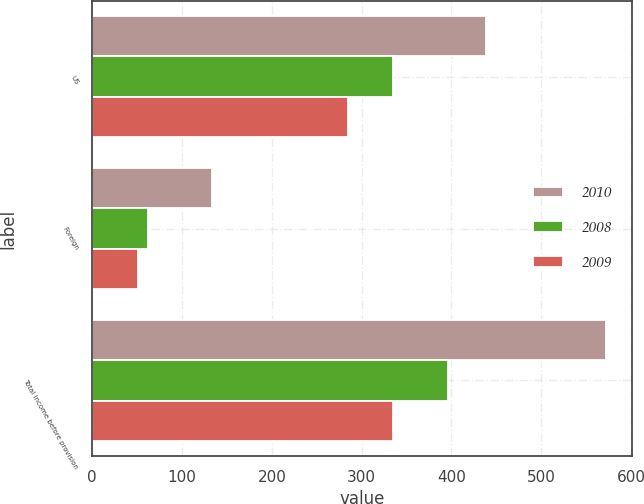Convert chart to OTSL. <chart><loc_0><loc_0><loc_500><loc_500><stacked_bar_chart><ecel><fcel>US<fcel>Foreign<fcel>Total income before provision<nl><fcel>2010<fcel>438.7<fcel>133.6<fcel>572.3<nl><fcel>2008<fcel>334.5<fcel>61.6<fcel>396.1<nl><fcel>2009<fcel>284.5<fcel>50.7<fcel>335.2<nl></chart> 